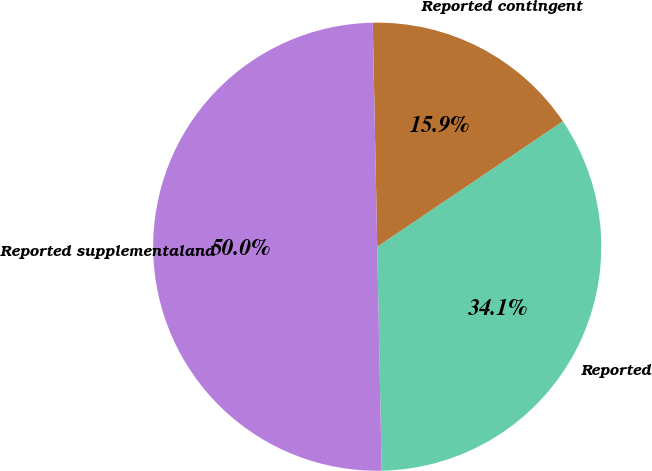Convert chart to OTSL. <chart><loc_0><loc_0><loc_500><loc_500><pie_chart><fcel>Reported<fcel>Reported contingent<fcel>Reported supplementaland<nl><fcel>34.14%<fcel>15.86%<fcel>50.0%<nl></chart> 